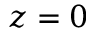Convert formula to latex. <formula><loc_0><loc_0><loc_500><loc_500>z = 0</formula> 